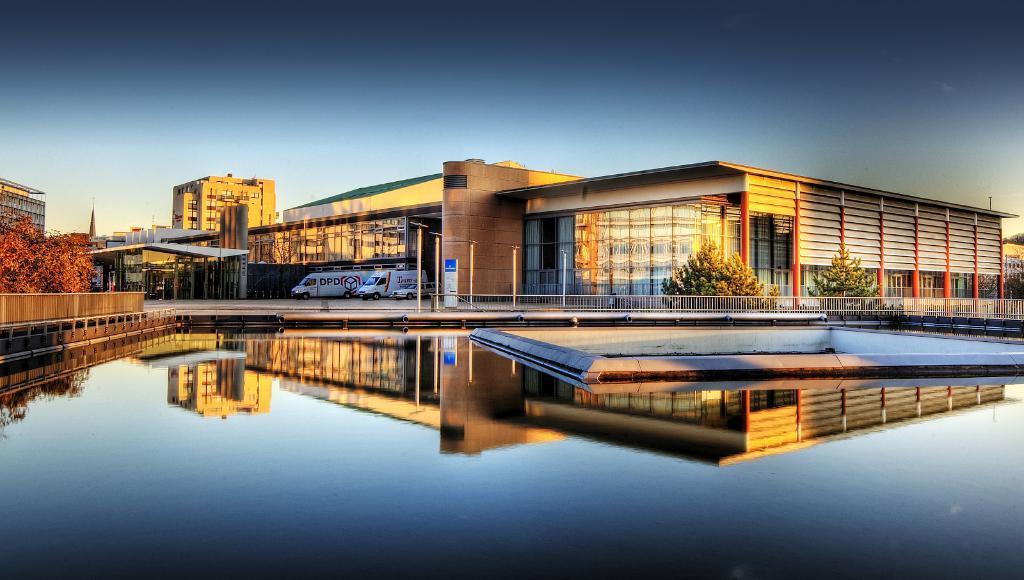How would you summarize this image in a sentence or two? We can see water and fence. On the background we can see buildings,trees,vehicles,poles and sky. 